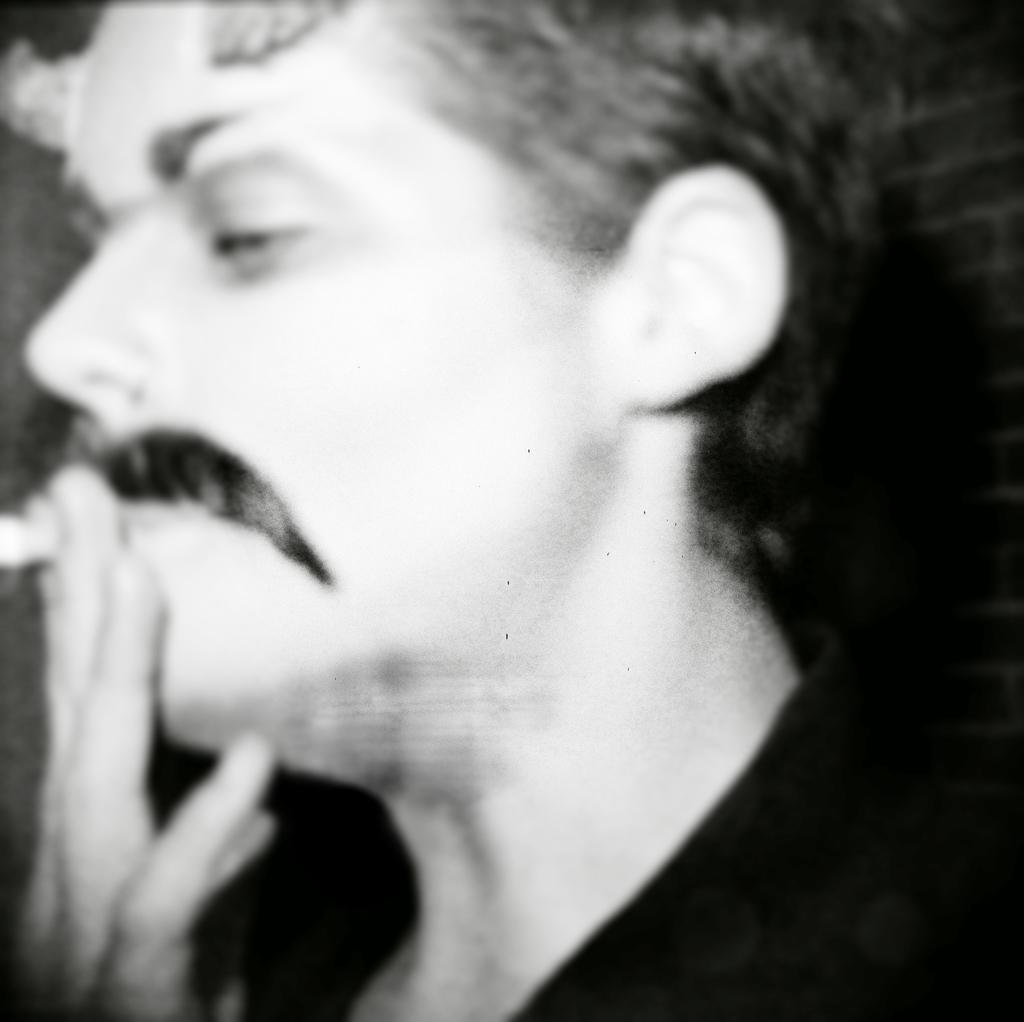Who is present in the image? There is a man in the image. What is the man holding in the image? The man is holding a communication device (com object) in the image. What can be seen on the right side of the image? There is a brick wall on the right side of the image. What type of paste is being used to write on the wall in the image? There is no paste or writing on the wall in the image; it is a brick wall. What color is the ink used for the suggestion on the communication device? There is no suggestion or ink present on the communication device in the image. 